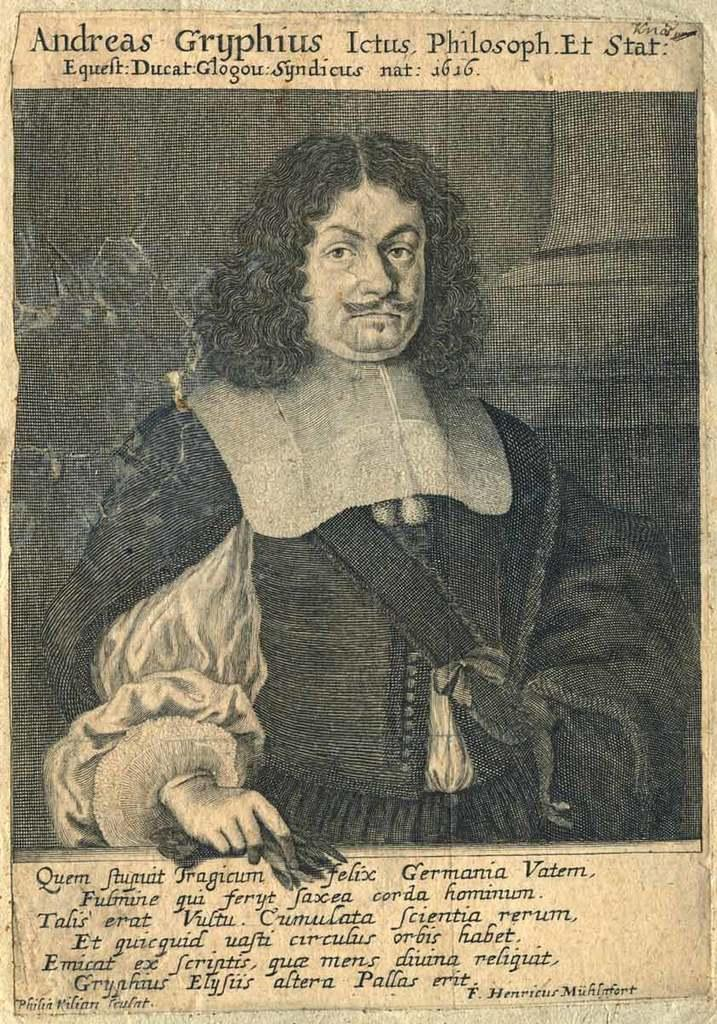What is the main subject of the image? The main subject of the image is a poster. What is depicted on the poster? The poster features a person. Where is text located in the image? There is text at the top and bottom of the image. What type of scarf is the person wearing in the image? There is no scarf visible in the image; the person is depicted on a poster. How many chairs are present in the image? There are no chairs present in the image; it features a poster with a person and text. 